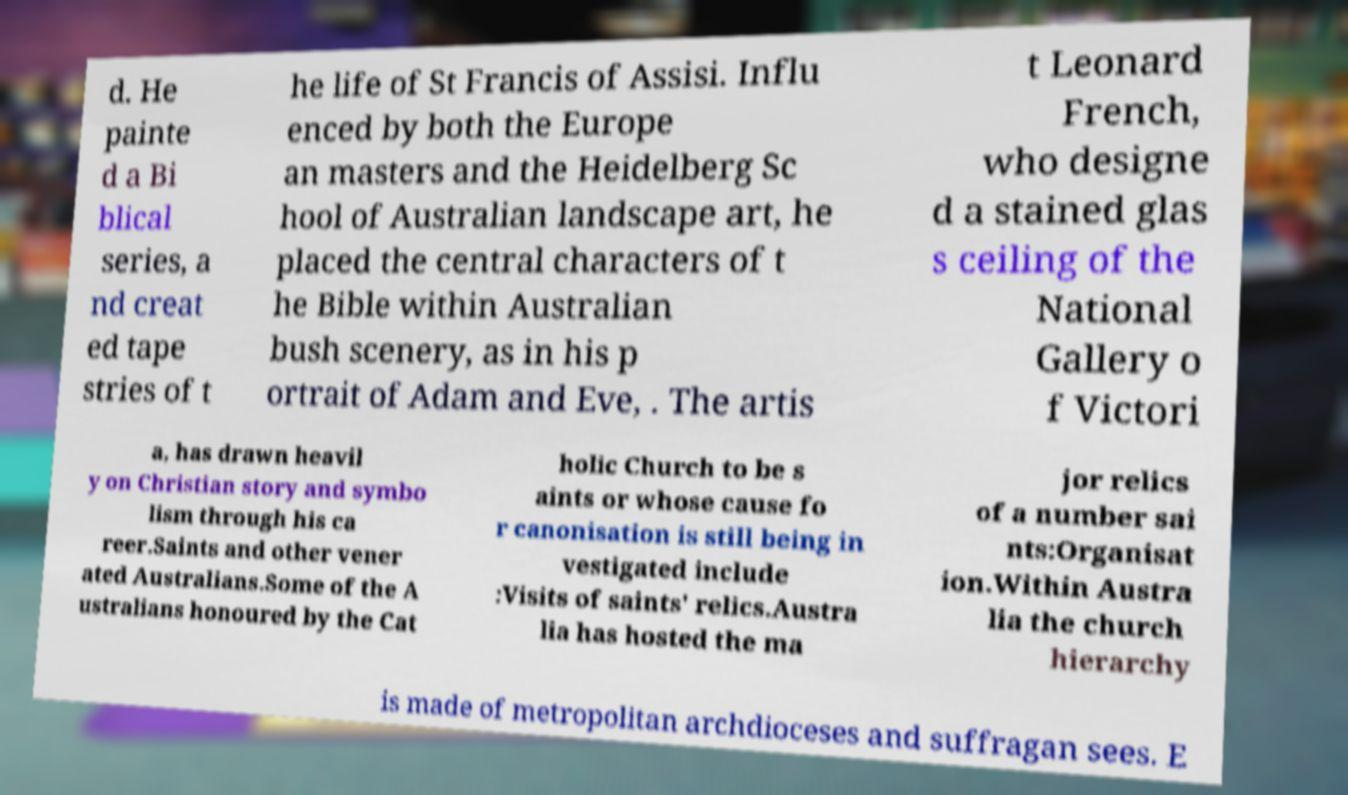For documentation purposes, I need the text within this image transcribed. Could you provide that? d. He painte d a Bi blical series, a nd creat ed tape stries of t he life of St Francis of Assisi. Influ enced by both the Europe an masters and the Heidelberg Sc hool of Australian landscape art, he placed the central characters of t he Bible within Australian bush scenery, as in his p ortrait of Adam and Eve, . The artis t Leonard French, who designe d a stained glas s ceiling of the National Gallery o f Victori a, has drawn heavil y on Christian story and symbo lism through his ca reer.Saints and other vener ated Australians.Some of the A ustralians honoured by the Cat holic Church to be s aints or whose cause fo r canonisation is still being in vestigated include :Visits of saints' relics.Austra lia has hosted the ma jor relics of a number sai nts:Organisat ion.Within Austra lia the church hierarchy is made of metropolitan archdioceses and suffragan sees. E 